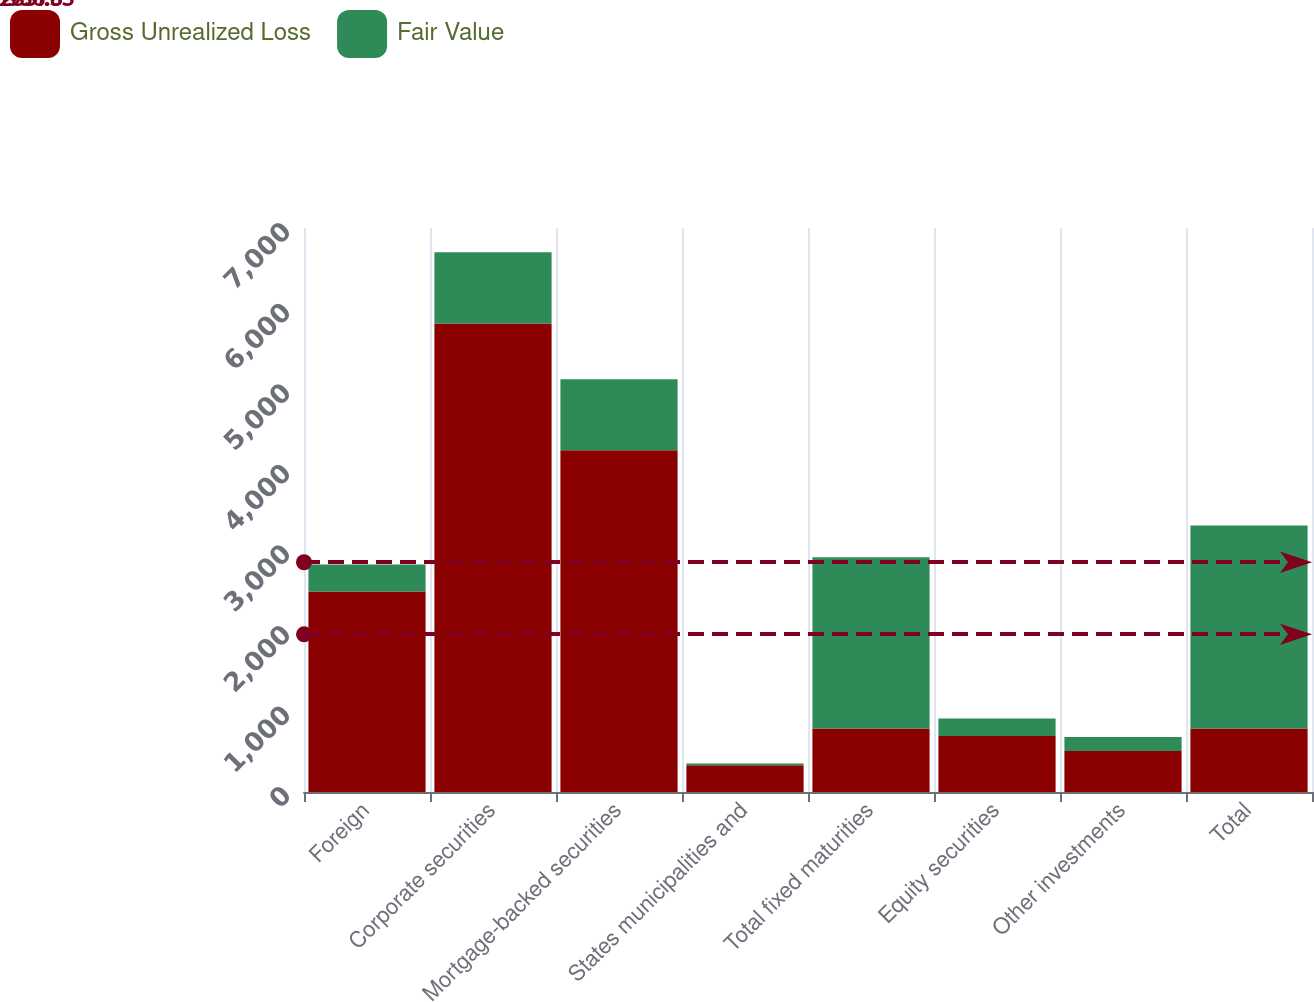<chart> <loc_0><loc_0><loc_500><loc_500><stacked_bar_chart><ecel><fcel>Foreign<fcel>Corporate securities<fcel>Mortgage-backed securities<fcel>States municipalities and<fcel>Total fixed maturities<fcel>Equity securities<fcel>Other investments<fcel>Total<nl><fcel>Gross Unrealized Loss<fcel>2488<fcel>5815<fcel>4242<fcel>331<fcel>787<fcel>694<fcel>508<fcel>787<nl><fcel>Fair Value<fcel>335.7<fcel>884.2<fcel>880<fcel>23.1<fcel>2125.5<fcel>217.7<fcel>175.9<fcel>2519.1<nl></chart> 